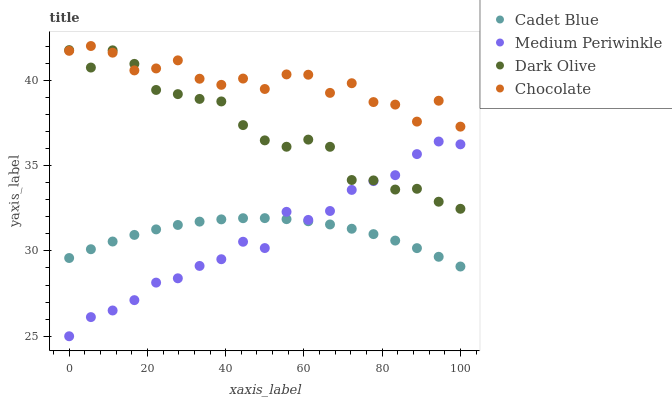Does Medium Periwinkle have the minimum area under the curve?
Answer yes or no. Yes. Does Chocolate have the maximum area under the curve?
Answer yes or no. Yes. Does Cadet Blue have the minimum area under the curve?
Answer yes or no. No. Does Cadet Blue have the maximum area under the curve?
Answer yes or no. No. Is Cadet Blue the smoothest?
Answer yes or no. Yes. Is Chocolate the roughest?
Answer yes or no. Yes. Is Medium Periwinkle the smoothest?
Answer yes or no. No. Is Medium Periwinkle the roughest?
Answer yes or no. No. Does Medium Periwinkle have the lowest value?
Answer yes or no. Yes. Does Cadet Blue have the lowest value?
Answer yes or no. No. Does Chocolate have the highest value?
Answer yes or no. Yes. Does Medium Periwinkle have the highest value?
Answer yes or no. No. Is Cadet Blue less than Chocolate?
Answer yes or no. Yes. Is Chocolate greater than Cadet Blue?
Answer yes or no. Yes. Does Dark Olive intersect Medium Periwinkle?
Answer yes or no. Yes. Is Dark Olive less than Medium Periwinkle?
Answer yes or no. No. Is Dark Olive greater than Medium Periwinkle?
Answer yes or no. No. Does Cadet Blue intersect Chocolate?
Answer yes or no. No. 